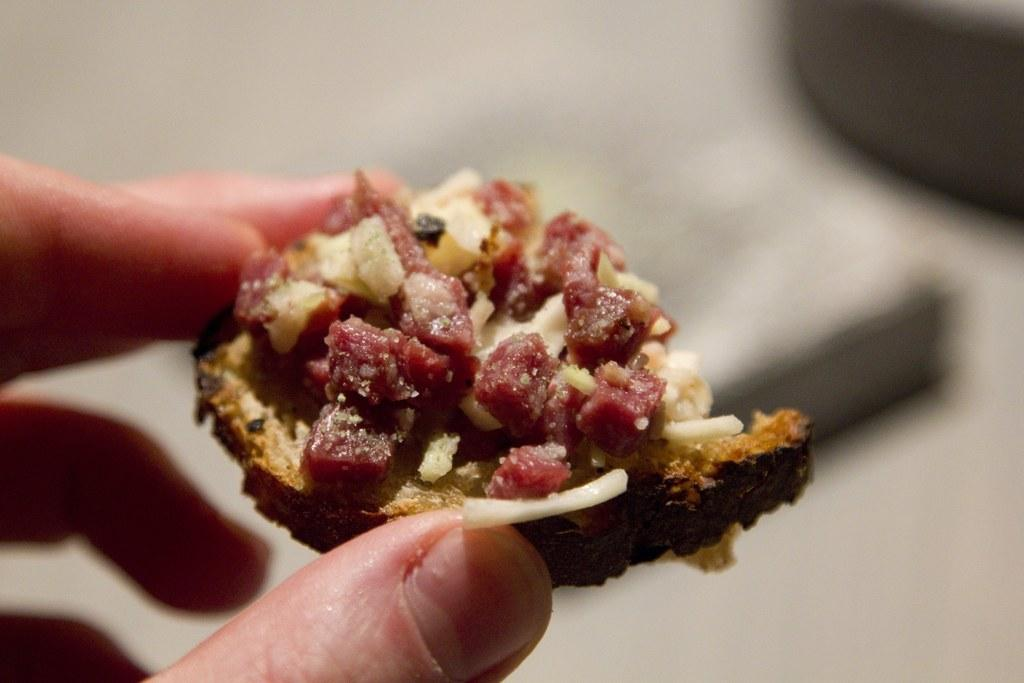What is the person's hand doing in the image? The person's hand is holding a food item in the image. Can you describe the colors of the food item? The food item has cream, brown, red, and orange colors. What can be observed about the background of the image? The background of the image is blurry. How many frogs are jumping on the person's hand in the image? There are no frogs present in the image; it only shows a person's hand holding a food item. 